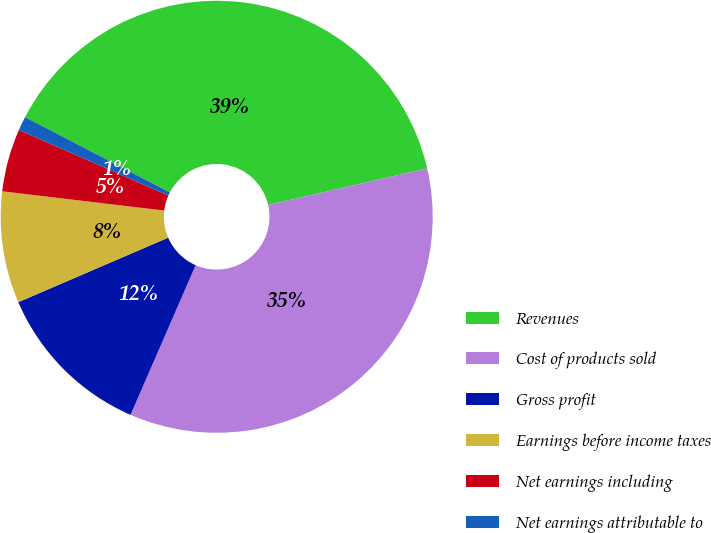Convert chart. <chart><loc_0><loc_0><loc_500><loc_500><pie_chart><fcel>Revenues<fcel>Cost of products sold<fcel>Gross profit<fcel>Earnings before income taxes<fcel>Net earnings including<fcel>Net earnings attributable to<nl><fcel>38.77%<fcel>35.12%<fcel>12.0%<fcel>8.35%<fcel>4.7%<fcel>1.05%<nl></chart> 